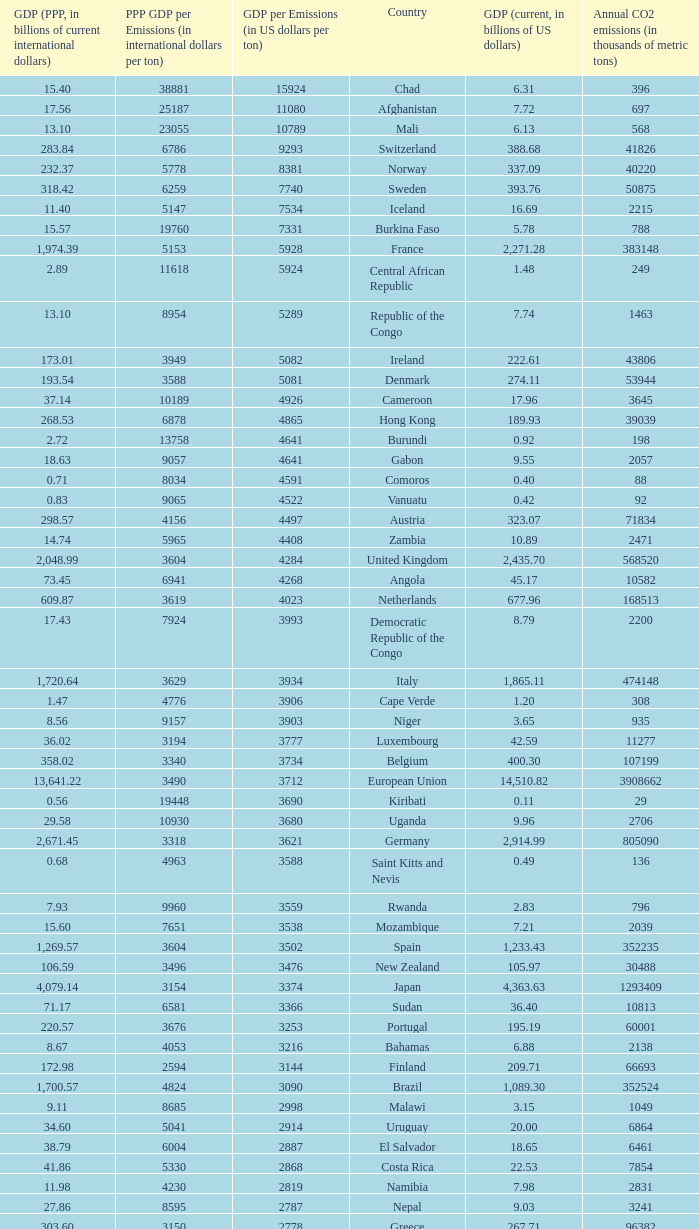When the gdp (current, in billions of us dollars) is 162.50, what is the gdp? 2562.0. 